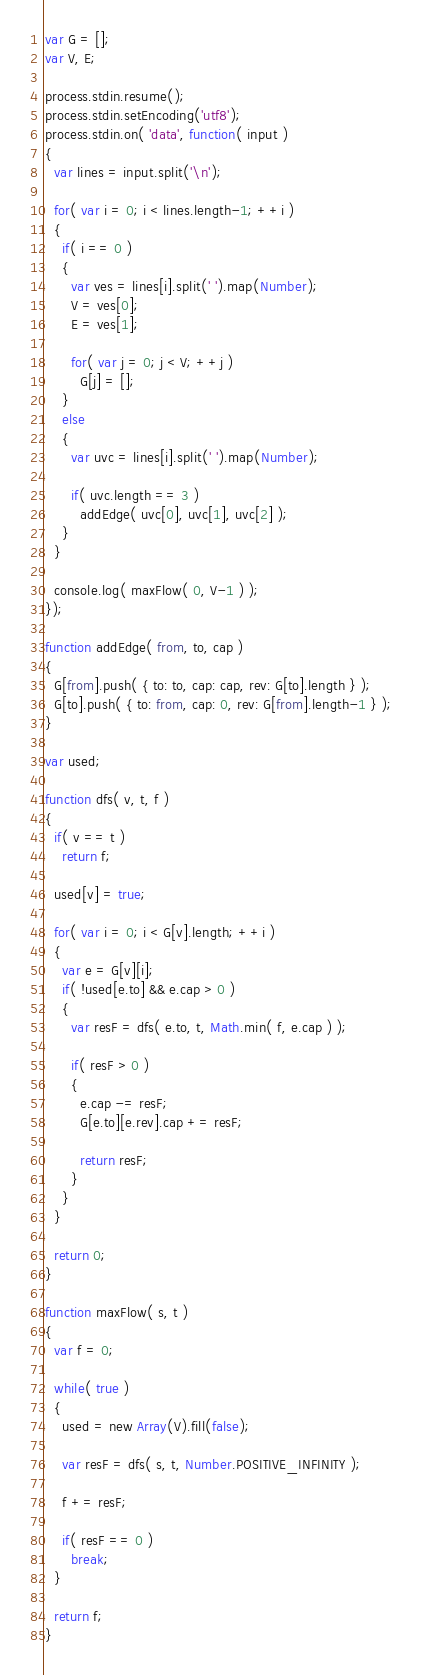Convert code to text. <code><loc_0><loc_0><loc_500><loc_500><_JavaScript_>var G = [];
var V, E;

process.stdin.resume();
process.stdin.setEncoding('utf8');
process.stdin.on( 'data', function( input )
{
  var lines = input.split('\n');

  for( var i = 0; i < lines.length-1; ++i )
  {
    if( i == 0 )
    {
      var ves = lines[i].split(' ').map(Number);
      V = ves[0];
      E = ves[1];

      for( var j = 0; j < V; ++j )
        G[j] = [];
    }
    else
    {
      var uvc = lines[i].split(' ').map(Number);

      if( uvc.length == 3 ) 
        addEdge( uvc[0], uvc[1], uvc[2] );
    }
  }

  console.log( maxFlow( 0, V-1 ) );
});

function addEdge( from, to, cap )
{
  G[from].push( { to: to, cap: cap, rev: G[to].length } );
  G[to].push( { to: from, cap: 0, rev: G[from].length-1 } );
}

var used;

function dfs( v, t, f )
{
  if( v == t )
    return f;

  used[v] = true;

  for( var i = 0; i < G[v].length; ++i )
  {
    var e = G[v][i];
    if( !used[e.to] && e.cap > 0 )
    {
      var resF = dfs( e.to, t, Math.min( f, e.cap ) );

      if( resF > 0 )
      {
        e.cap -= resF;
        G[e.to][e.rev].cap += resF;

        return resF;
      }
    }
  }

  return 0;
}

function maxFlow( s, t )
{
  var f = 0;

  while( true )
  {
    used = new Array(V).fill(false);

    var resF = dfs( s, t, Number.POSITIVE_INFINITY );

    f += resF;

    if( resF == 0 )
      break;
  }

  return f;
}</code> 